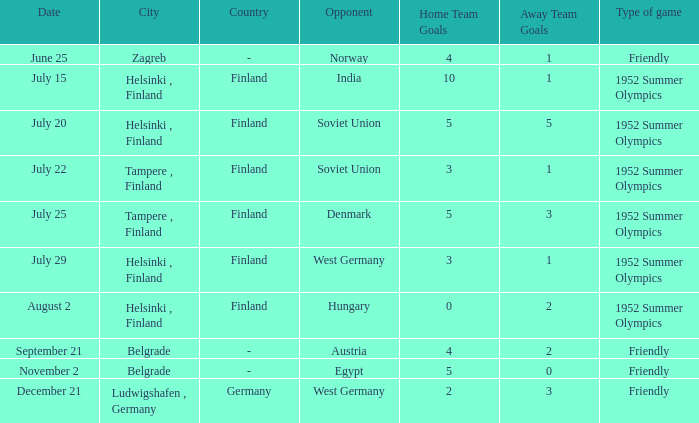What is the Results¹ that was a friendly game and played on June 25? 4:1. 